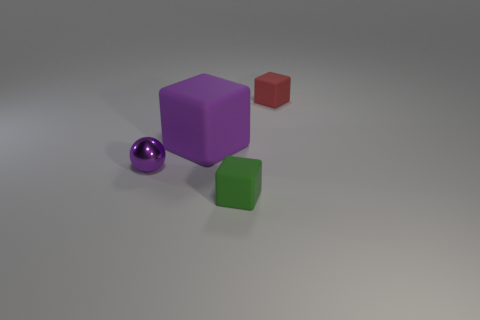There is a matte thing that is the same color as the tiny metal ball; what is its size?
Your response must be concise. Large. There is a thing that is the same color as the big block; what is it made of?
Your response must be concise. Metal. Is there anything else that has the same size as the purple block?
Provide a short and direct response. No. What number of other things are there of the same color as the small ball?
Ensure brevity in your answer.  1. What number of cyan things are either balls or objects?
Keep it short and to the point. 0. What is the material of the cube on the right side of the green rubber object?
Offer a terse response. Rubber. Is the material of the small green thing that is in front of the large rubber object the same as the purple cube?
Give a very brief answer. Yes. There is a purple matte object; what shape is it?
Your response must be concise. Cube. How many green matte objects are to the left of the small rubber block behind the small cube in front of the red rubber object?
Make the answer very short. 1. What number of other things are made of the same material as the red block?
Provide a short and direct response. 2. 